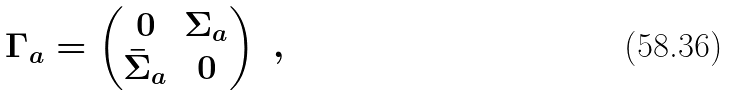<formula> <loc_0><loc_0><loc_500><loc_500>\Gamma _ { a } = \begin{pmatrix} 0 & \Sigma _ { a } \\ \bar { \Sigma } _ { a } & 0 \end{pmatrix} \ ,</formula> 